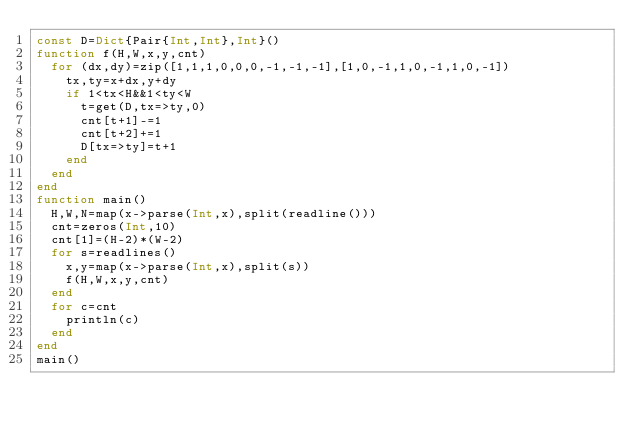Convert code to text. <code><loc_0><loc_0><loc_500><loc_500><_Julia_>const D=Dict{Pair{Int,Int},Int}()
function f(H,W,x,y,cnt)
	for (dx,dy)=zip([1,1,1,0,0,0,-1,-1,-1],[1,0,-1,1,0,-1,1,0,-1])
		tx,ty=x+dx,y+dy
		if 1<tx<H&&1<ty<W
			t=get(D,tx=>ty,0)
			cnt[t+1]-=1
			cnt[t+2]+=1
			D[tx=>ty]=t+1
		end
	end
end
function main()
	H,W,N=map(x->parse(Int,x),split(readline()))
	cnt=zeros(Int,10)
	cnt[1]=(H-2)*(W-2)
	for s=readlines()
		x,y=map(x->parse(Int,x),split(s))
		f(H,W,x,y,cnt)
	end
  for c=cnt
    println(c)
  end
end
main()
</code> 